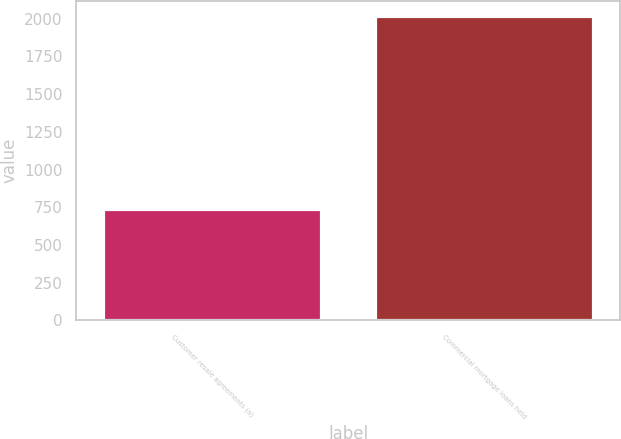Convert chart. <chart><loc_0><loc_0><loc_500><loc_500><bar_chart><fcel>Customer resale agreements (a)<fcel>Commercial mortgage loans held<nl><fcel>738<fcel>2018<nl></chart> 